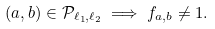Convert formula to latex. <formula><loc_0><loc_0><loc_500><loc_500>( a , b ) \in \mathcal { P } _ { \ell _ { 1 } , \ell _ { 2 } } \implies f _ { a , b } \neq 1 .</formula> 